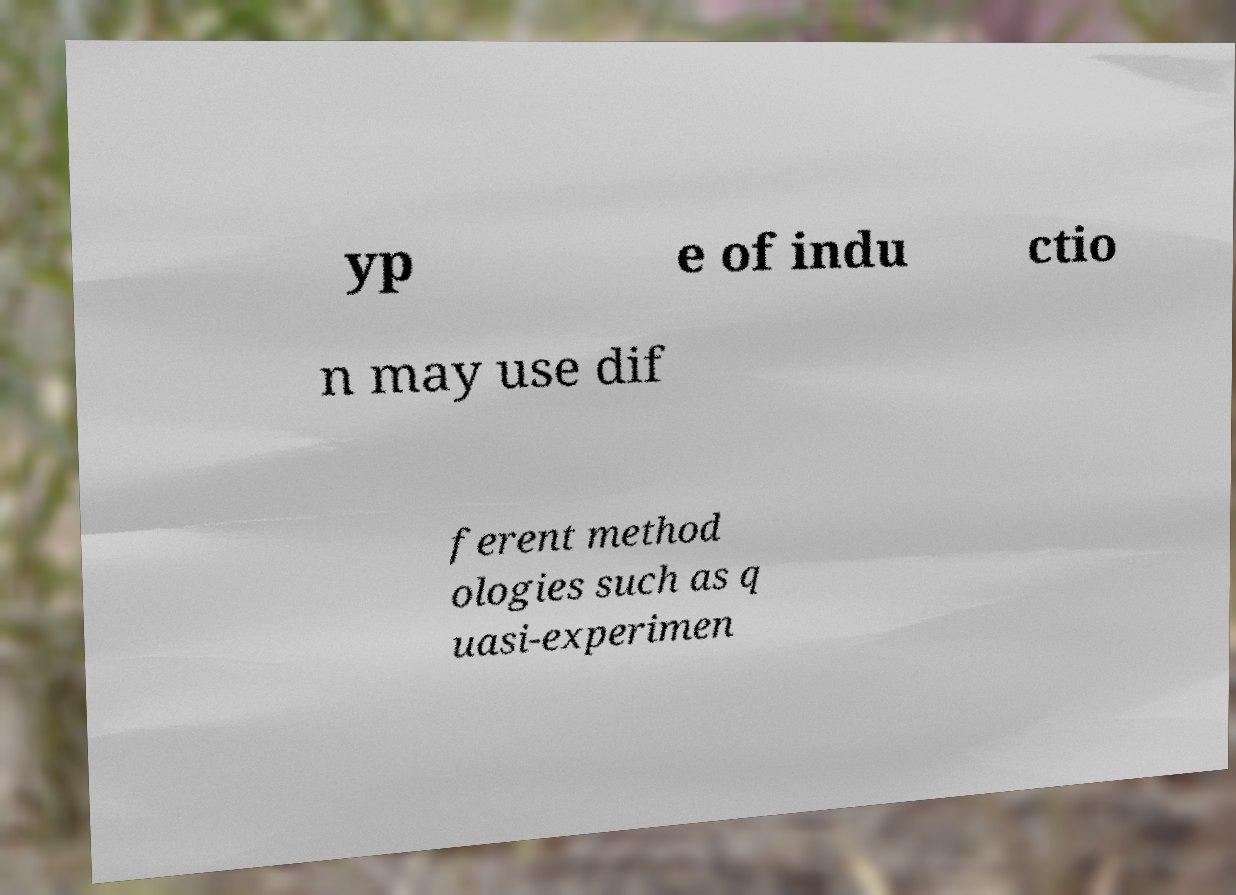Can you accurately transcribe the text from the provided image for me? yp e of indu ctio n may use dif ferent method ologies such as q uasi-experimen 